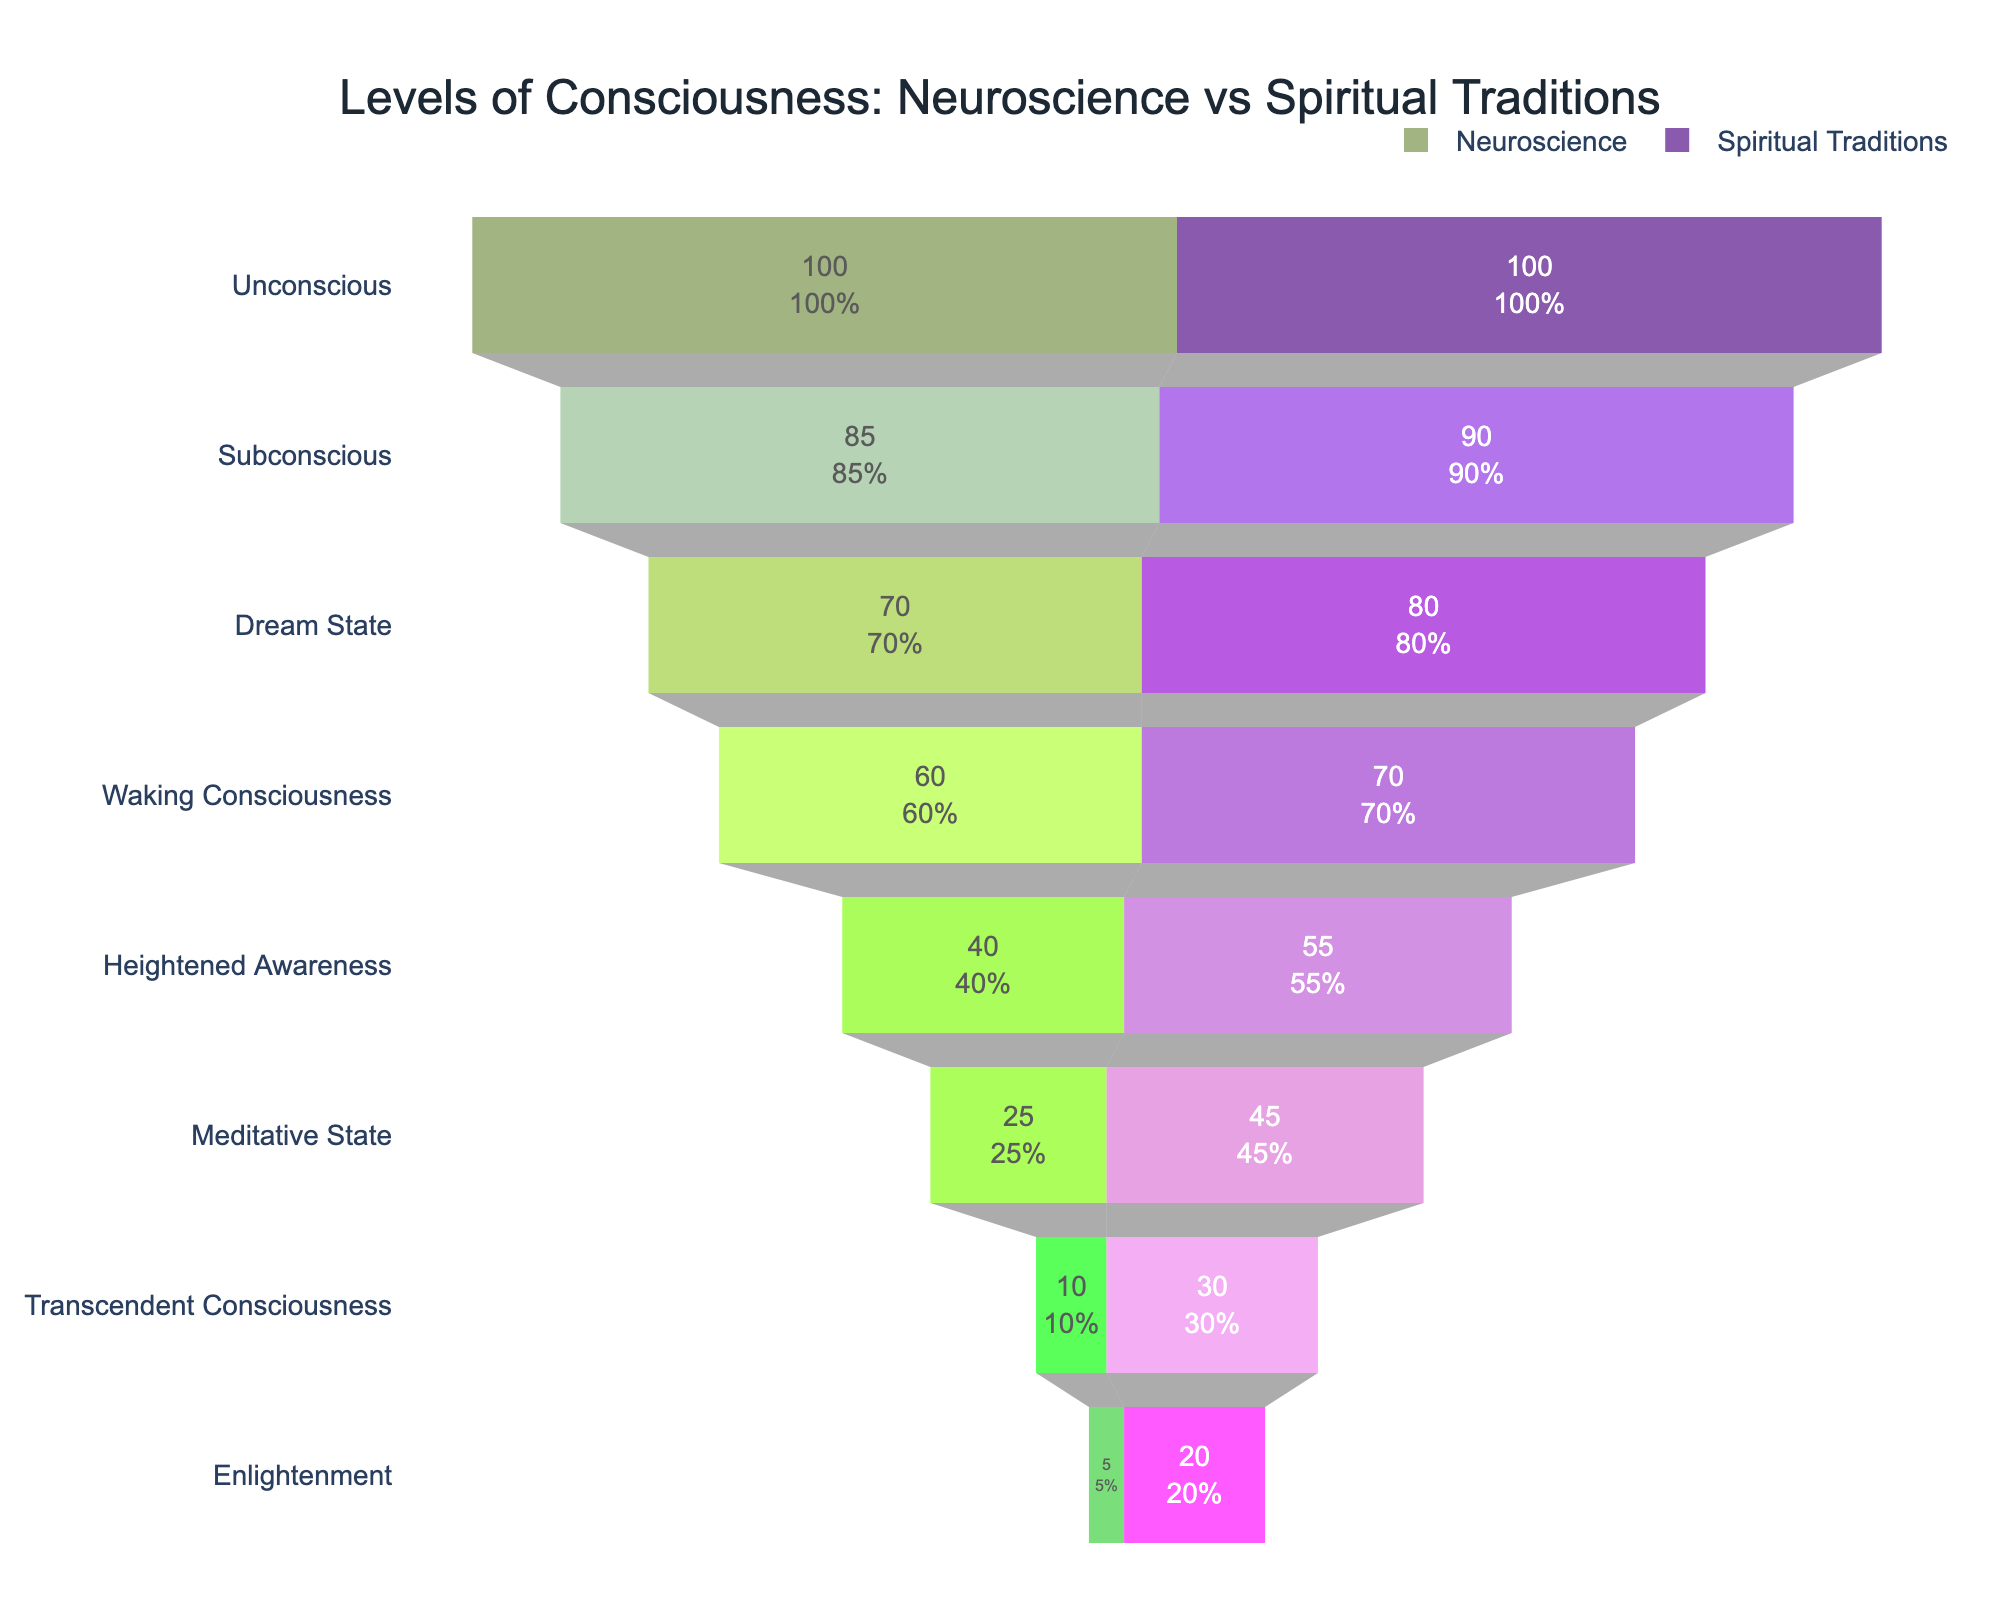Which level of consciousness appears at the top of the funnel chart? The top level of the funnel chart is "Unconscious" in both Neuroscience and Spiritual Traditions.
Answer: Unconscious How many levels of consciousness are represented in the funnel chart? The chart shows 8 levels of consciousness, as indicated by the y-axis labels.
Answer: 8 What is the percentage of Transcendent Consciousness in Neuroscience compared to the initial value? The percentage can be calculated by dividing the value of Transcendent Consciousness by the initial value and multiplying by 100. For Neuroscience, it is (10 / 100) * 100%.
Answer: 10% Which level of consciousness has the largest difference in values between Neuroscience and Spiritual Traditions? Subtract the value of each pair of levels from each other. The level with the largest difference is "Enlightenment" with a difference of 15 (20 - 5).
Answer: Enlightenment Which tradition reports higher values for Waking Consciousness, Neuroscience or Spiritual Traditions? By comparing the values for Waking Consciousness, Spiritual Traditions reports a higher value of 70 compared to Neuroscience's 60.
Answer: Spiritual Traditions What's the total value sum of Meditative State in both Neuroscience and Spiritual Traditions? Add the values for Meditative State in both traditions: 25 (Neuroscience) + 45 (Spiritual Traditions) = 70.
Answer: 70 Compare the trends of decline from Unconscious to Enlightenment between Neuroscience and Spiritual Traditions. Which one has a steeper overall decline? To determine the steepness, compare the initial and final values in both traditions. Neuroscience declines from 100 to 5, and Spiritual Traditions from 100 to 20. The decline for Neuroscience is more significant (95 units) compared to Spiritual Traditions (80 units).
Answer: Neuroscience What is the value difference for Heightened Awareness between Neuroscience and Spiritual Traditions? The difference is calculated by subtracting the Neuroscience value (40) from the Spiritual Traditions value (55), resulting in a difference of 15.
Answer: 15 What percentage of the Spiritual Traditions' initial value is at the level of Enlightenment? The percentage is calculated by (20 / 100) * 100%, resulting in a 20% value for Enlightenment in Spiritual Traditions.
Answer: 20% 